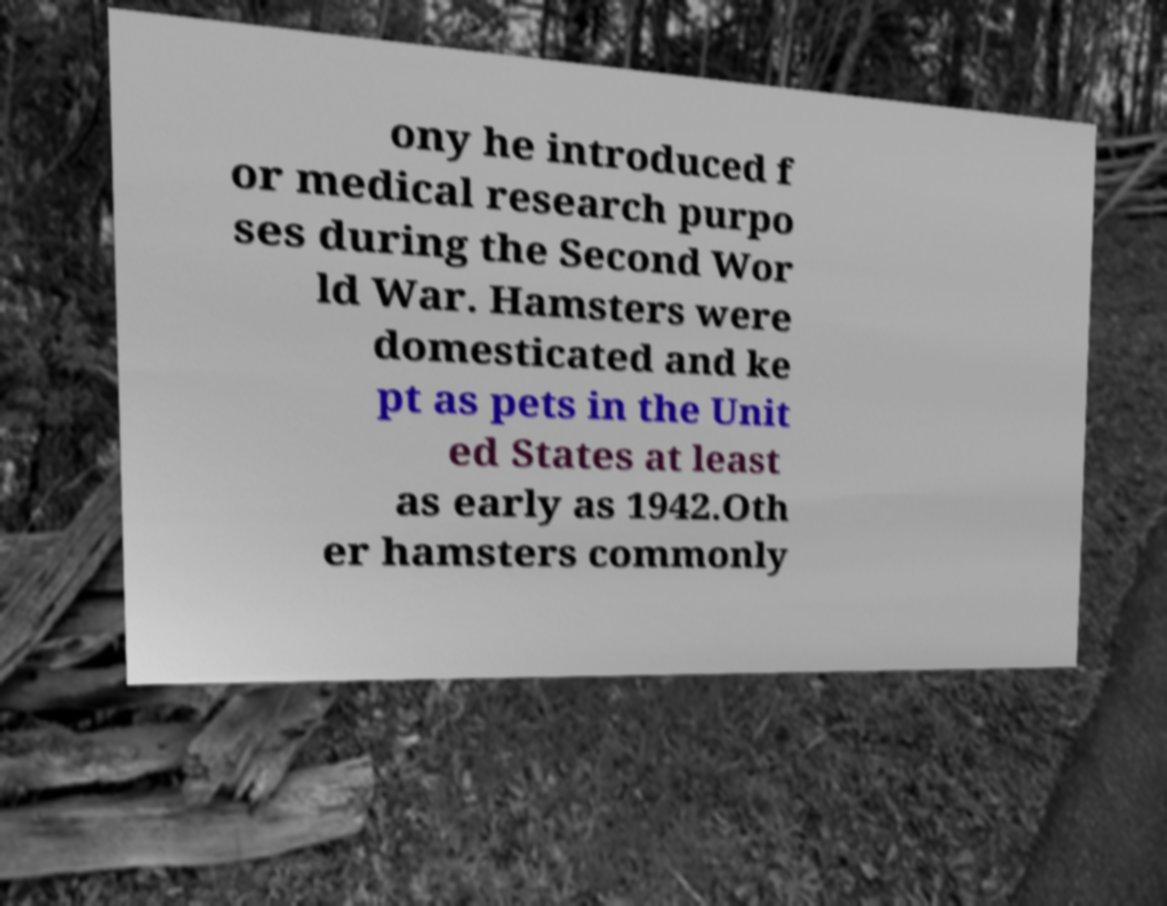There's text embedded in this image that I need extracted. Can you transcribe it verbatim? ony he introduced f or medical research purpo ses during the Second Wor ld War. Hamsters were domesticated and ke pt as pets in the Unit ed States at least as early as 1942.Oth er hamsters commonly 